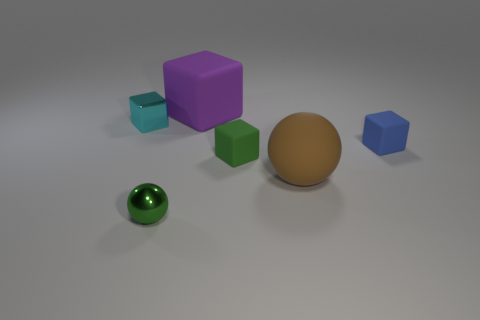How many things are tiny matte blocks left of the brown ball or gray cylinders?
Keep it short and to the point. 1. What number of other things are there of the same color as the tiny shiny ball?
Make the answer very short. 1. Are there the same number of purple cubes that are in front of the brown matte thing and large brown balls?
Your response must be concise. No. There is a big rubber thing that is behind the metallic thing left of the small metal ball; what number of tiny green matte cubes are on the left side of it?
Your answer should be compact. 0. Are there any other things that have the same size as the blue block?
Provide a succinct answer. Yes. There is a brown rubber ball; is its size the same as the sphere that is left of the purple rubber block?
Your answer should be compact. No. What number of big purple cubes are there?
Provide a short and direct response. 1. There is a green thing right of the green metal sphere; is its size the same as the cube on the right side of the rubber ball?
Your answer should be very brief. Yes. What color is the other object that is the same shape as the green shiny object?
Ensure brevity in your answer.  Brown. Is the shape of the tiny green metallic thing the same as the brown matte object?
Offer a very short reply. Yes. 